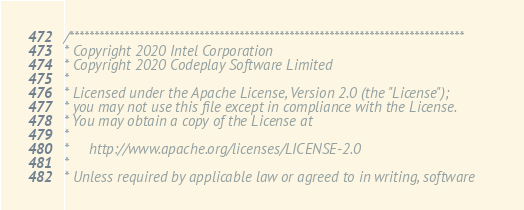<code> <loc_0><loc_0><loc_500><loc_500><_C++_>/*******************************************************************************
* Copyright 2020 Intel Corporation
* Copyright 2020 Codeplay Software Limited
*
* Licensed under the Apache License, Version 2.0 (the "License");
* you may not use this file except in compliance with the License.
* You may obtain a copy of the License at
*
*     http://www.apache.org/licenses/LICENSE-2.0
*
* Unless required by applicable law or agreed to in writing, software</code> 